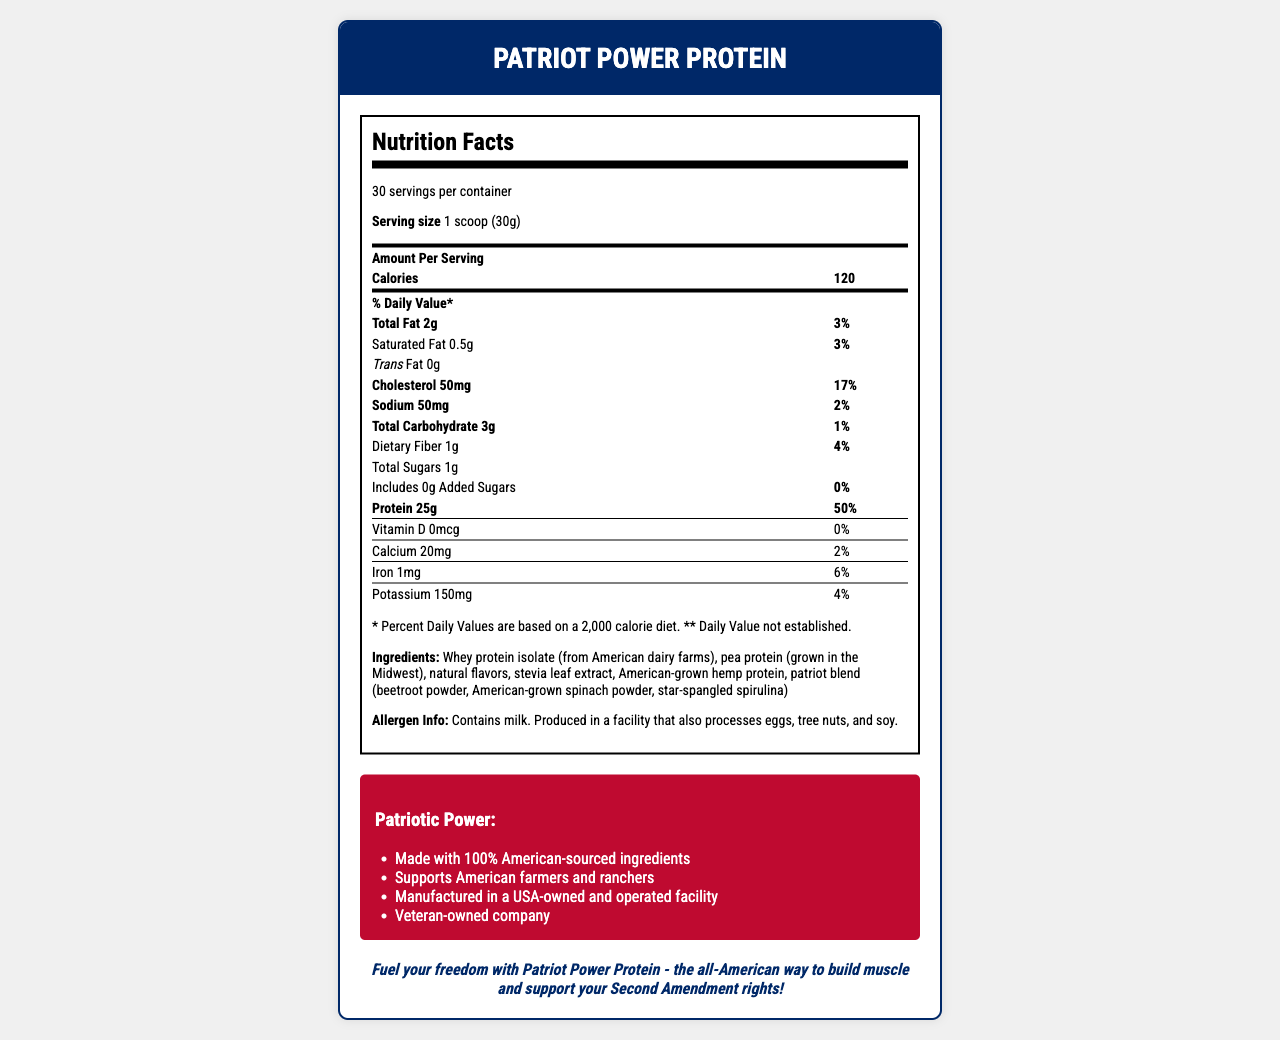What is the serving size for Patriot Power Protein? The serving size is clearly mentioned as "1 scoop (30g)" at the top of the Nutrition Facts section.
Answer: 1 scoop (30g) How many servings are there in one container of Patriot Power Protein? The number of servings per container is stated as 30 at the top of the Nutrition Facts section.
Answer: 30 How much protein does one serving of Patriot Power Protein provide? The amount of protein per serving is listed as 25g under the "Protein" section in the Nutrition Facts.
Answer: 25g What percentage of the daily value of protein does one serving provide? It is mentioned in the Nutrition Facts section that one serving provides 50% of the daily value for protein.
Answer: 50% Does Patriot Power Protein contain any added sugars? The Nutrition Facts state that it includes 0g of added sugars, which is 0% of the daily value.
Answer: No Which ingredient is used for sweetness in the Patriot Power Protein? A. Sugar B. Aspartame C. Sucralose D. Stevia Leaf Extract The ingredients list includes "stevia leaf extract," indicating that it is used for sweetness.
Answer: D What is the source of the whey protein isolate in this product? A. International dairy farms B. American dairy farms C. Canadian dairy farms D. European dairy farms The ingredients list indicates that the whey protein isolate is sourced from American dairy farms.
Answer: B True or False: The Patriot Power Protein is manufactured in an overseas facility. The document states that it is manufactured in a USA-owned and operated facility.
Answer: False Describe the main idea of the document. The document's primary purpose is to convey the nutritional content and patriotic claims of the product, emphasizing its American roots and values.
Answer: The document provides the Nutrition Facts and ingredient information for Patriot Power Protein, a protein powder made with American-sourced ingredients. It supports American farmers and is manufactured in a USA-owned and operated facility. It also includes additional nutrients like BCAAs, L-Glutamine, and Creatine Monohydrate. What is the total fat content per serving? The Nutrition Facts section lists the total fat amount as 2g per serving.
Answer: 2g What is the daily value percentage for cholesterol in one serving? In the Nutrition Facts, the cholesterol amount is given as 50mg with a daily value percentage of 17%.
Answer: 17% What is the combined total of Branched Chain Amino Acids (BCAAs) and L-Glutamine in one serving? The supplement facts state that BCAAs are 5.5g and L-Glutamine is 2g. The sum is 7.5g.
Answer: 7.5g What is the amount of added dietary fiber in one serving? The dietary fiber content is listed as 1g in the Nutrition Facts.
Answer: 1g Is the Patriot Power Protein vegan-friendly? The document doesn't provide information on whether the product is vegan-friendly, although it contains whey protein isolate, which is derived from milk.
Answer: Cannot be determined What are the patriotic claims made by the Patriot Power Protein? The claims are listed in the patriotic claims section of the document.
Answer: Made with 100% American-sourced ingredients, Supports American farmers and ranchers, Manufactured in a USA-owned and operated facility, Veteran-owned company What is the amount of calcium provided by one serving, and what percentage of the daily value does it represent? The Nutrition Facts state that one serving contains 20mg of calcium, representing 2% of the daily value.
Answer: 20mg, 2% What are the ingredients in the "patriot blend"? The ingredients section lists these as part of the patriot blend included in the product.
Answer: Beetroot powder, American-grown spinach powder, star-spangled spirulina 